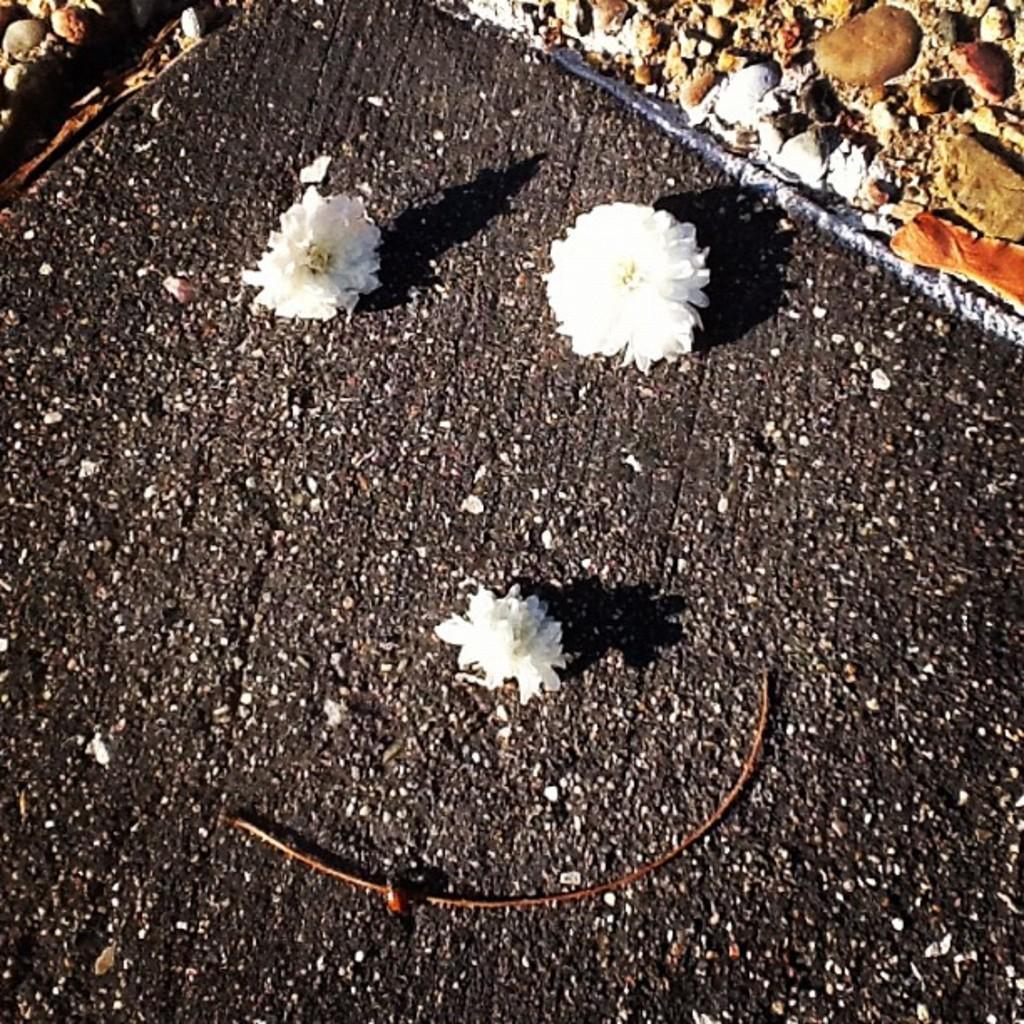Please provide a concise description of this image. There are 3 white flowers and there are stones at the back. 